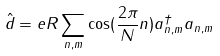<formula> <loc_0><loc_0><loc_500><loc_500>\hat { d } = e R \sum _ { n , m } \cos ( \frac { 2 \pi } { N } n ) a ^ { \dagger } _ { n , m } a _ { n , m }</formula> 